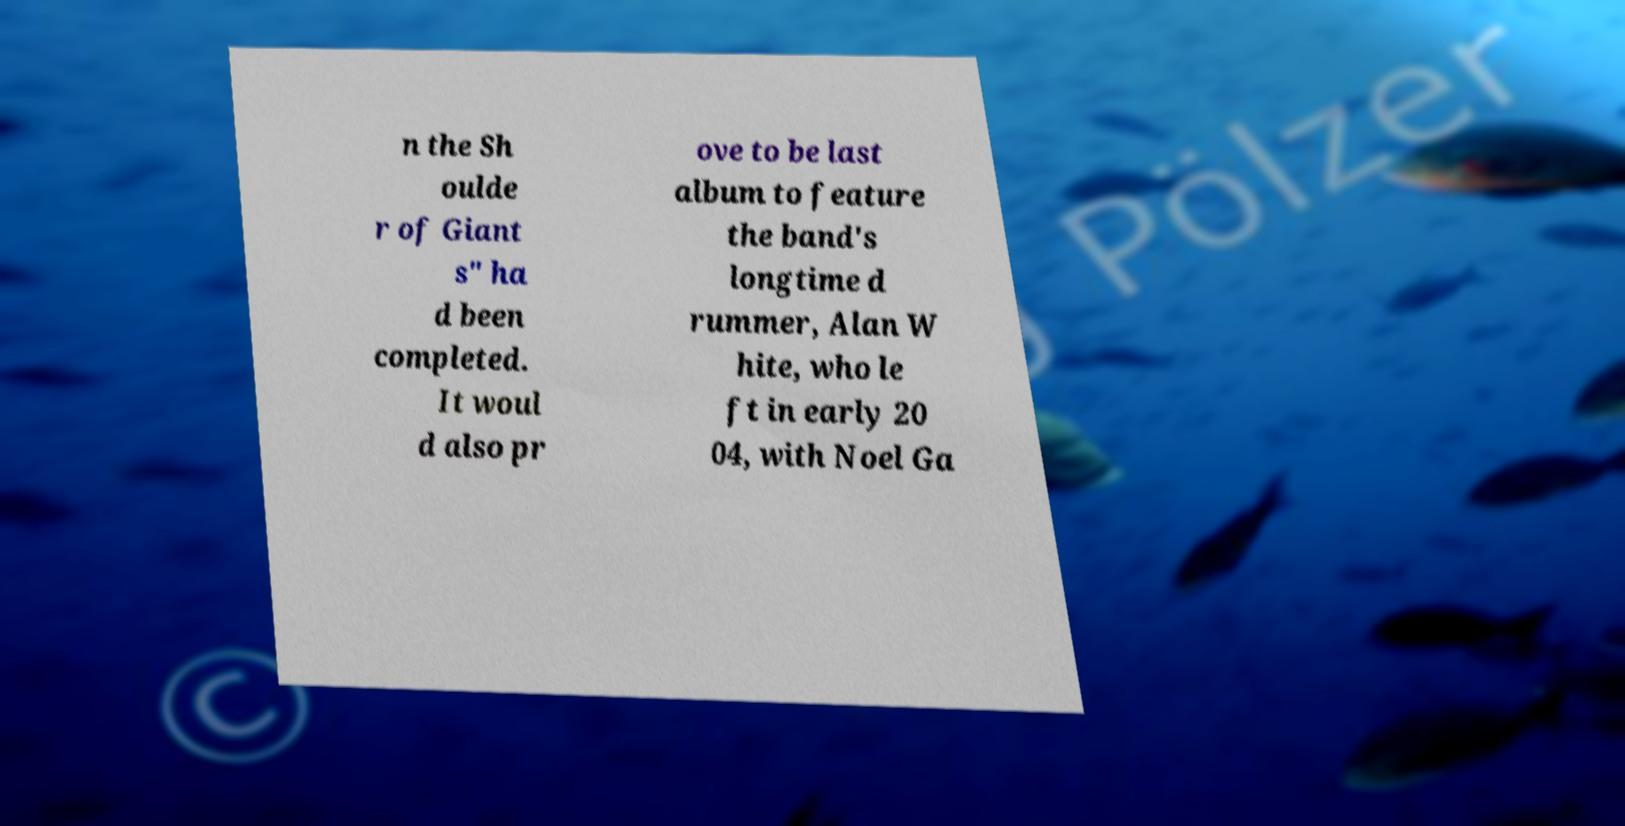For documentation purposes, I need the text within this image transcribed. Could you provide that? n the Sh oulde r of Giant s" ha d been completed. It woul d also pr ove to be last album to feature the band's longtime d rummer, Alan W hite, who le ft in early 20 04, with Noel Ga 